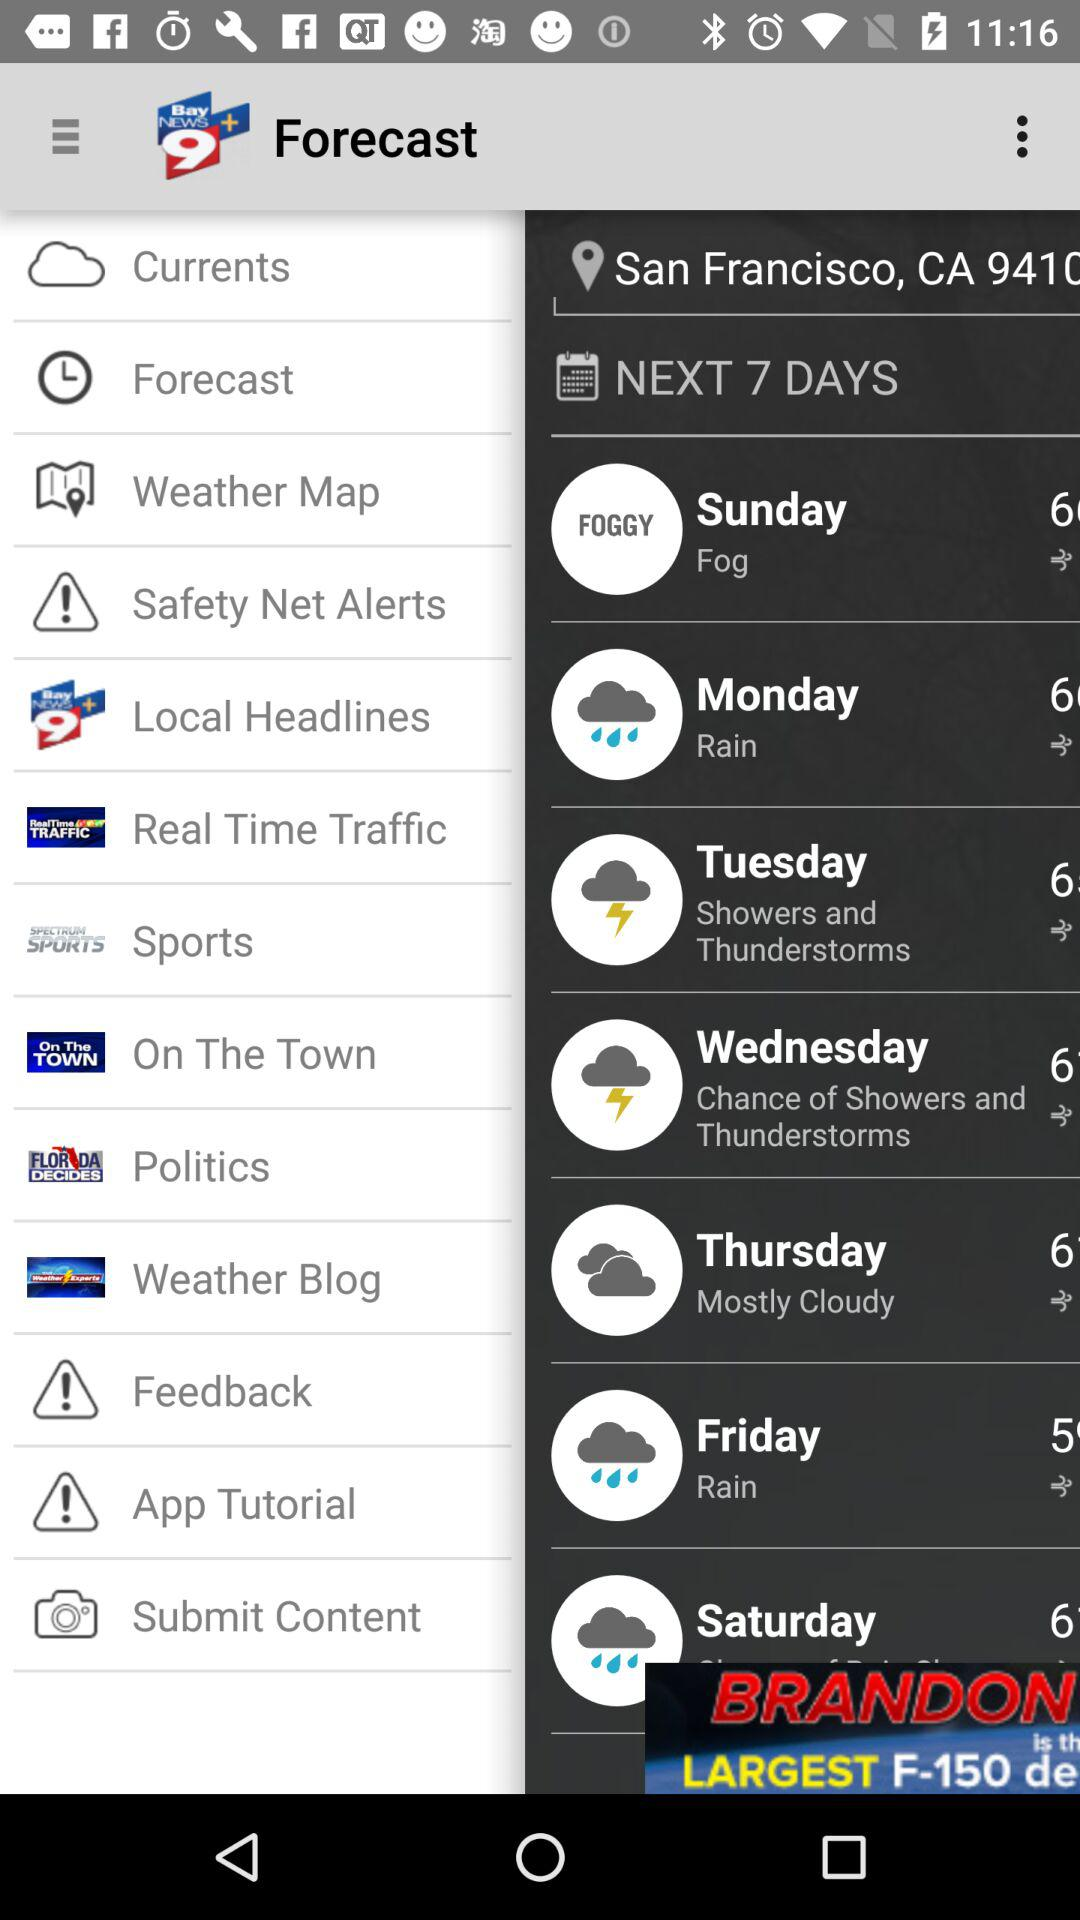What is the weather forecast for Friday? The weather forecast is rainy. 